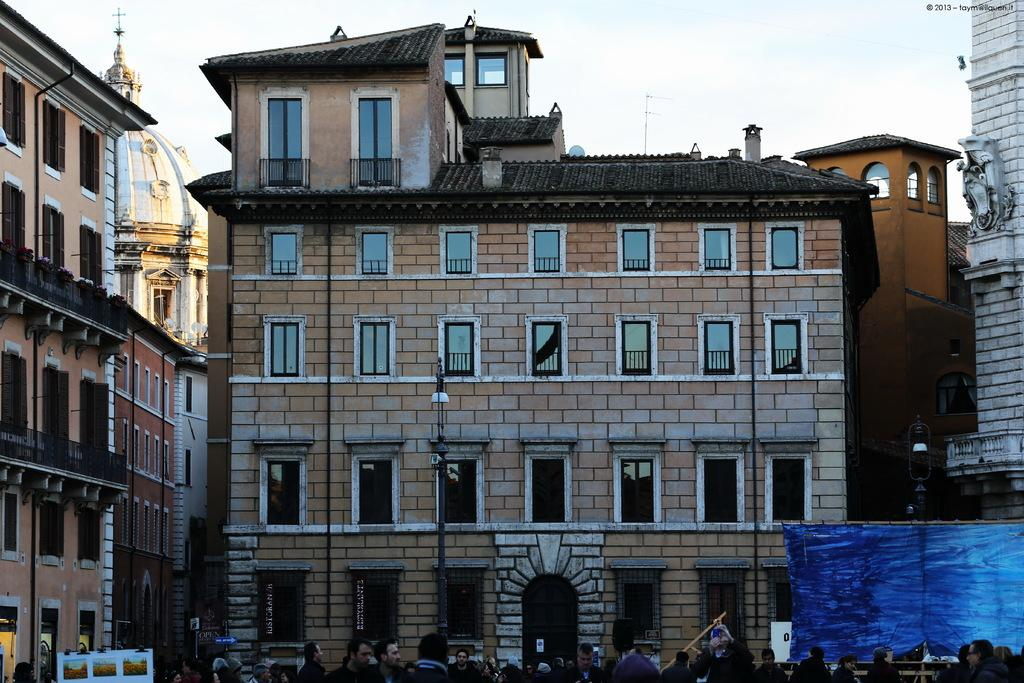How many people are in the image? There is a group of people in the image, but the exact number is not specified. What are the people in the image doing? The people are standing in the image. What can be seen behind the people? There is a banner visible behind the people. What other objects are present in the image? There are poles in the image. What can be seen in the background of the image? There are buildings and the sky visible in the background of the image. What year is depicted on the bell in the image? There is no bell present in the image, so the year cannot be determined. 